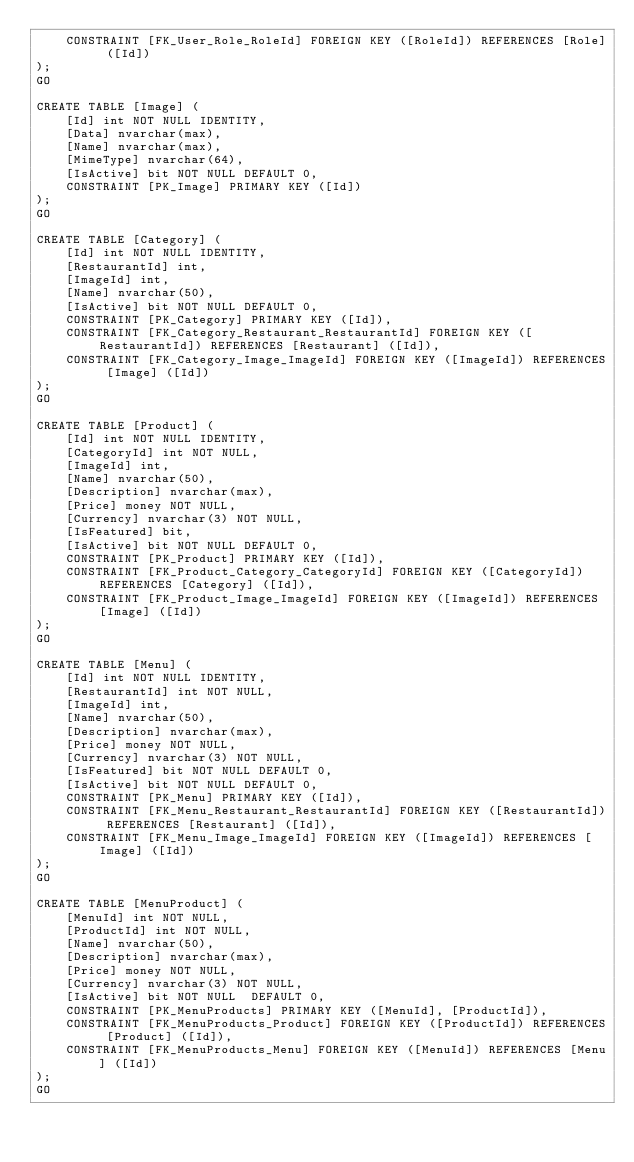Convert code to text. <code><loc_0><loc_0><loc_500><loc_500><_SQL_>	CONSTRAINT [FK_User_Role_RoleId] FOREIGN KEY ([RoleId]) REFERENCES [Role] ([Id])
);
GO

CREATE TABLE [Image] (
    [Id] int NOT NULL IDENTITY,
	[Data] nvarchar(max),
	[Name] nvarchar(max),
	[MimeType] nvarchar(64),
	[IsActive] bit NOT NULL DEFAULT 0,
    CONSTRAINT [PK_Image] PRIMARY KEY ([Id])
);
GO

CREATE TABLE [Category] (
    [Id] int NOT NULL IDENTITY,
    [RestaurantId] int,
	[ImageId] int,
	[Name] nvarchar(50),
	[IsActive] bit NOT NULL DEFAULT 0,
    CONSTRAINT [PK_Category] PRIMARY KEY ([Id]),
	CONSTRAINT [FK_Category_Restaurant_RestaurantId] FOREIGN KEY ([RestaurantId]) REFERENCES [Restaurant] ([Id]),
	CONSTRAINT [FK_Category_Image_ImageId] FOREIGN KEY ([ImageId]) REFERENCES [Image] ([Id])
);
GO

CREATE TABLE [Product] (
    [Id] int NOT NULL IDENTITY,
	[CategoryId] int NOT NULL,
	[ImageId] int,
    [Name] nvarchar(50),
    [Description] nvarchar(max),
    [Price] money NOT NULL,
    [Currency] nvarchar(3) NOT NULL,
    [IsFeatured] bit,
	[IsActive] bit NOT NULL DEFAULT 0,
    CONSTRAINT [PK_Product] PRIMARY KEY ([Id]),
	CONSTRAINT [FK_Product_Category_CategoryId] FOREIGN KEY ([CategoryId]) REFERENCES [Category] ([Id]),
	CONSTRAINT [FK_Product_Image_ImageId] FOREIGN KEY ([ImageId]) REFERENCES [Image] ([Id])
);
GO

CREATE TABLE [Menu] (
    [Id] int NOT NULL IDENTITY,
	[RestaurantId] int NOT NULL,
	[ImageId] int,
    [Name] nvarchar(50),
    [Description] nvarchar(max),
    [Price] money NOT NULL,
    [Currency] nvarchar(3) NOT NULL,
    [IsFeatured] bit NOT NULL DEFAULT 0,
	[IsActive] bit NOT NULL DEFAULT 0,
    CONSTRAINT [PK_Menu] PRIMARY KEY ([Id]),
	CONSTRAINT [FK_Menu_Restaurant_RestaurantId] FOREIGN KEY ([RestaurantId]) REFERENCES [Restaurant] ([Id]),
	CONSTRAINT [FK_Menu_Image_ImageId] FOREIGN KEY ([ImageId]) REFERENCES [Image] ([Id])
);
GO

CREATE TABLE [MenuProduct] (
	[MenuId] int NOT NULL,
	[ProductId] int NOT NULL,
    [Name] nvarchar(50),
    [Description] nvarchar(max),
    [Price] money NOT NULL,
    [Currency] nvarchar(3) NOT NULL,
	[IsActive] bit NOT NULL  DEFAULT 0,
    CONSTRAINT [PK_MenuProducts] PRIMARY KEY ([MenuId], [ProductId]),
	CONSTRAINT [FK_MenuProducts_Product] FOREIGN KEY ([ProductId]) REFERENCES [Product] ([Id]),
	CONSTRAINT [FK_MenuProducts_Menu] FOREIGN KEY ([MenuId]) REFERENCES [Menu] ([Id])
);
GO




</code> 